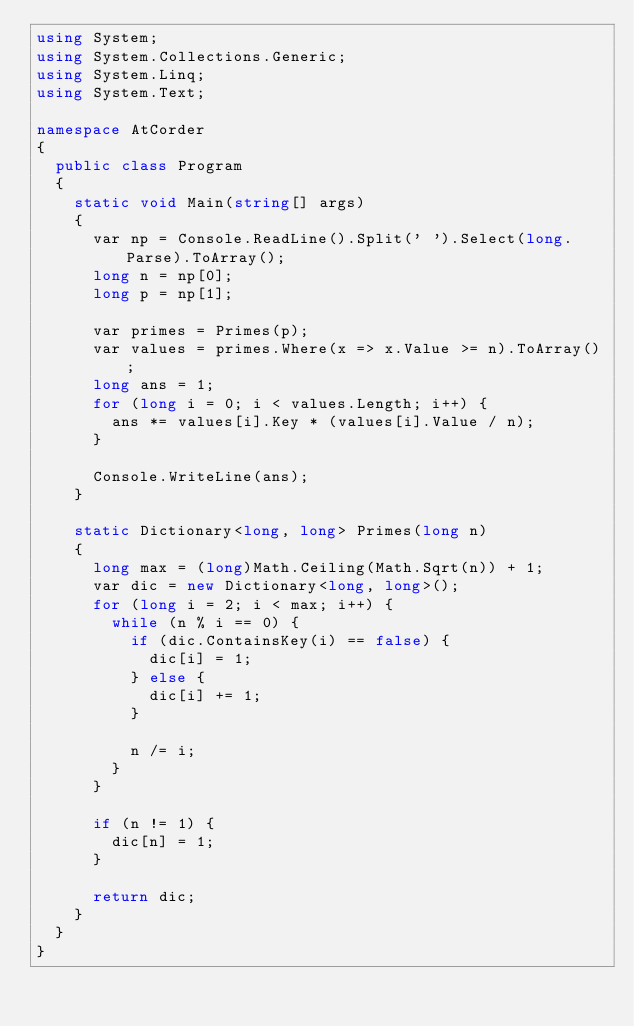Convert code to text. <code><loc_0><loc_0><loc_500><loc_500><_C#_>using System;
using System.Collections.Generic;
using System.Linq;
using System.Text;

namespace AtCorder
{
	public class Program
	{
		static void Main(string[] args)
		{
			var np = Console.ReadLine().Split(' ').Select(long.Parse).ToArray();
			long n = np[0];
			long p = np[1];

			var primes = Primes(p);
			var values = primes.Where(x => x.Value >= n).ToArray();
			long ans = 1;
			for (long i = 0; i < values.Length; i++) {
				ans *= values[i].Key * (values[i].Value / n);
			}

			Console.WriteLine(ans);
		}

		static Dictionary<long, long> Primes(long n)
		{
			long max = (long)Math.Ceiling(Math.Sqrt(n)) + 1;
			var dic = new Dictionary<long, long>();
			for (long i = 2; i < max; i++) {
				while (n % i == 0) {
					if (dic.ContainsKey(i) == false) {
						dic[i] = 1;
					} else {
						dic[i] += 1;
					}

					n /= i;
				}
			}

			if (n != 1) {
				dic[n] = 1;
			}

			return dic;
		}
	}
}
</code> 